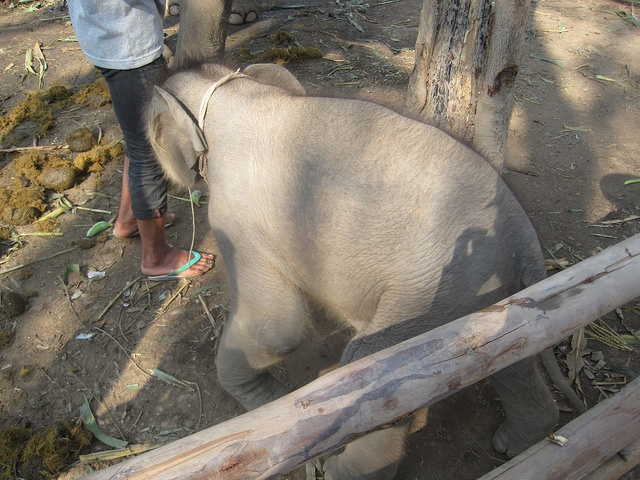Describe the objects in this image and their specific colors. I can see elephant in black, darkgray, gray, and tan tones and people in black, gray, and darkgray tones in this image. 